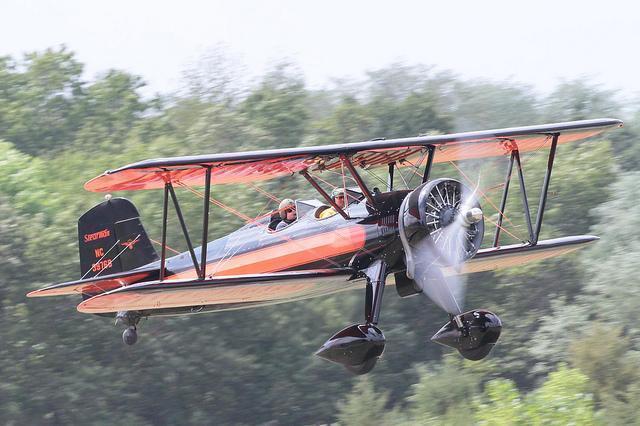How many people are in the plane?
Give a very brief answer. 2. 